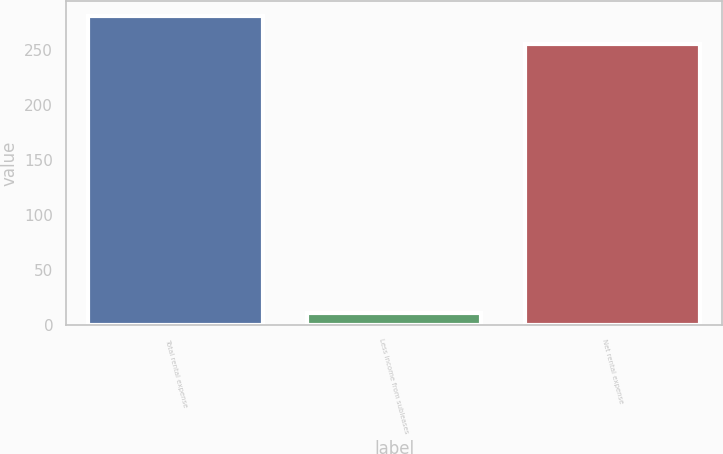Convert chart to OTSL. <chart><loc_0><loc_0><loc_500><loc_500><bar_chart><fcel>Total rental expense<fcel>Less income from subleases<fcel>Net rental expense<nl><fcel>280.5<fcel>11<fcel>255<nl></chart> 